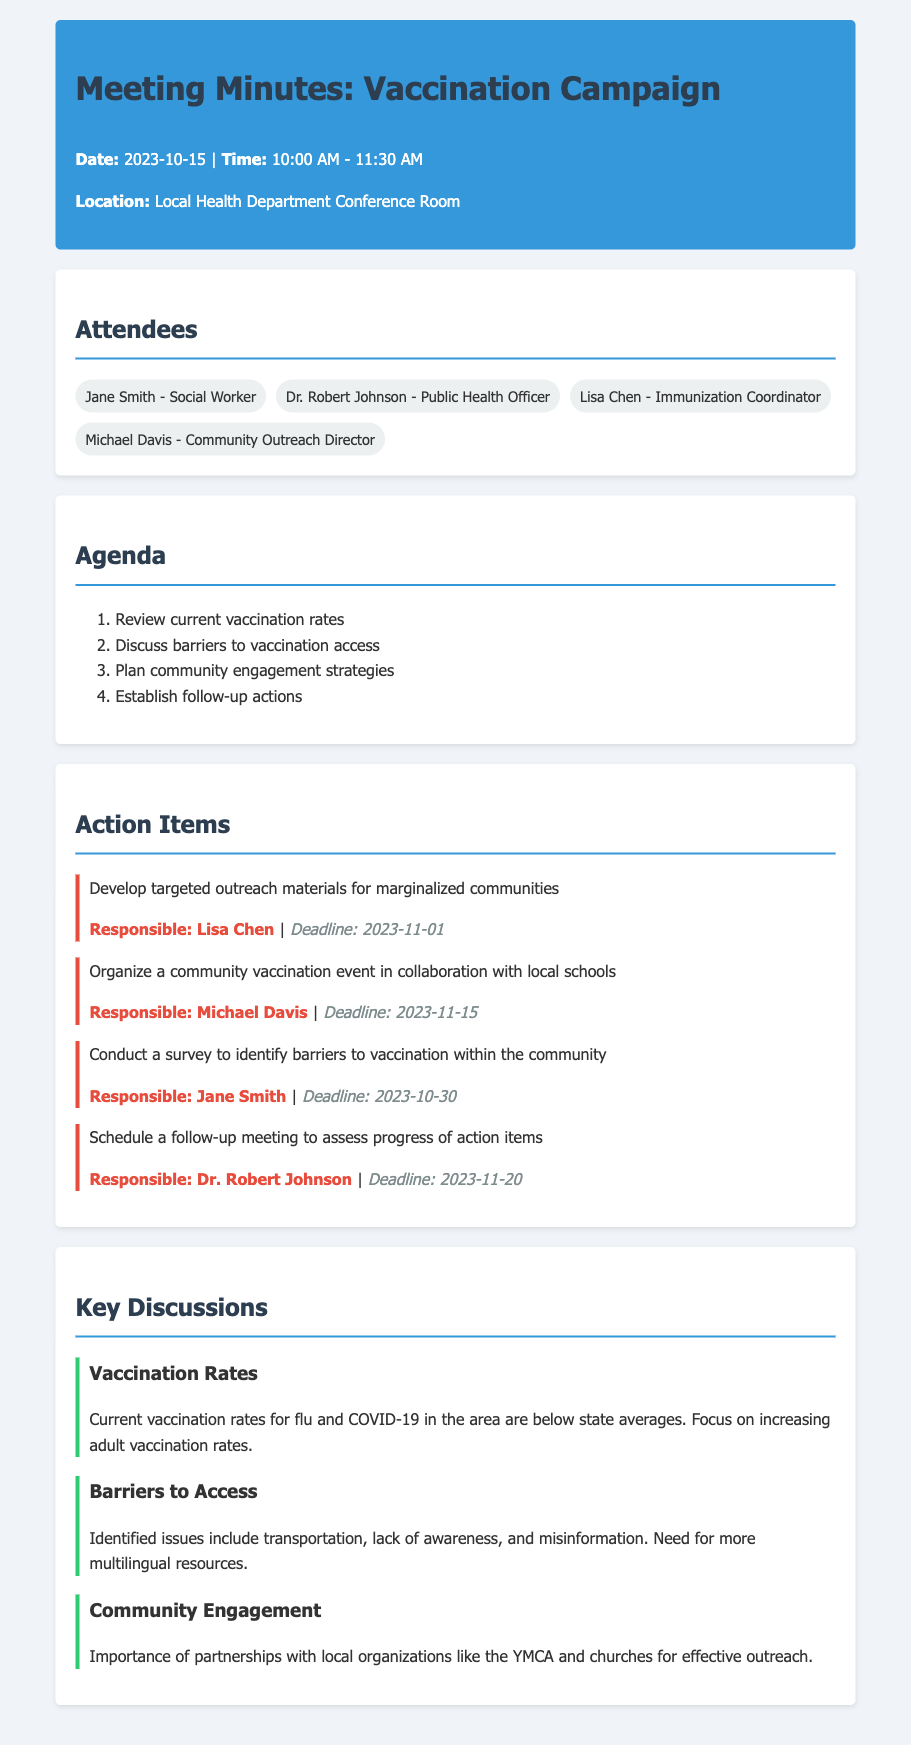what is the date of the meeting? The date of the meeting is specified in the header section of the document.
Answer: 2023-10-15 who is responsible for developing outreach materials? The document lists the responsible person for each action item. Lisa Chen is responsible for developing targeted outreach materials.
Answer: Lisa Chen what is the deadline for the community vaccination event? The deadline for each action item is provided alongside it in the action items section.
Answer: 2023-11-15 what are two identified barriers to vaccination? The barriers to vaccination are discussed in one of the sections, where specific issues are mentioned.
Answer: Transportation, lack of awareness who will conduct the survey on barriers to vaccination? The action items section clearly indicates who is responsible for each task, including the survey.
Answer: Jane Smith what is the primary focus of the current vaccination campaign? The document mentions the need to focus on adult vaccination rates in the discussion about vaccination rates.
Answer: Increasing adult vaccination rates when is the follow-up meeting scheduled? The deadline for the follow-up meeting is specified in the action items section.
Answer: 2023-11-20 which local organizations are mentioned for effective outreach? The key discussions highlight the importance of partnerships with local organizations specifically.
Answer: YMCA and churches 